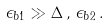Convert formula to latex. <formula><loc_0><loc_0><loc_500><loc_500>\epsilon _ { b 1 } \gg \Delta \, , \, \epsilon _ { b 2 } \, .</formula> 